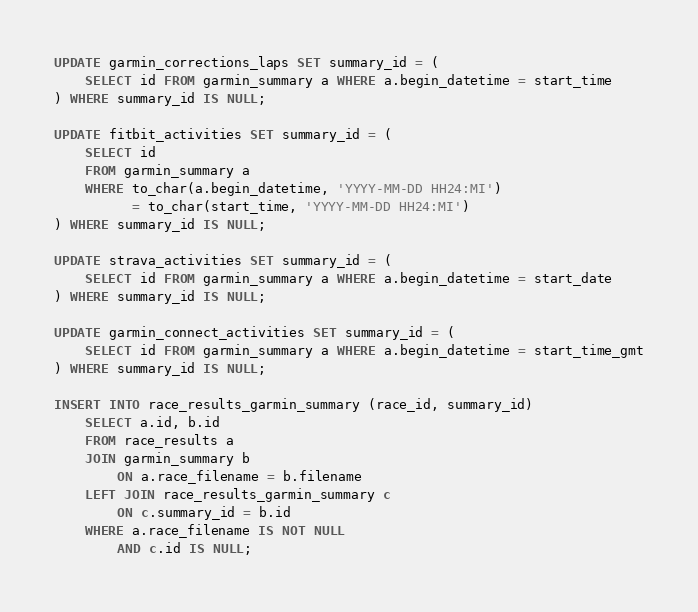Convert code to text. <code><loc_0><loc_0><loc_500><loc_500><_SQL_>UPDATE garmin_corrections_laps SET summary_id = (
    SELECT id FROM garmin_summary a WHERE a.begin_datetime = start_time
) WHERE summary_id IS NULL;

UPDATE fitbit_activities SET summary_id = (
    SELECT id
    FROM garmin_summary a
    WHERE to_char(a.begin_datetime, 'YYYY-MM-DD HH24:MI')
          = to_char(start_time, 'YYYY-MM-DD HH24:MI')
) WHERE summary_id IS NULL;

UPDATE strava_activities SET summary_id = (
    SELECT id FROM garmin_summary a WHERE a.begin_datetime = start_date
) WHERE summary_id IS NULL;

UPDATE garmin_connect_activities SET summary_id = (
    SELECT id FROM garmin_summary a WHERE a.begin_datetime = start_time_gmt
) WHERE summary_id IS NULL;

INSERT INTO race_results_garmin_summary (race_id, summary_id)
    SELECT a.id, b.id
    FROM race_results a
    JOIN garmin_summary b
        ON a.race_filename = b.filename
    LEFT JOIN race_results_garmin_summary c
        ON c.summary_id = b.id
    WHERE a.race_filename IS NOT NULL
        AND c.id IS NULL;
</code> 